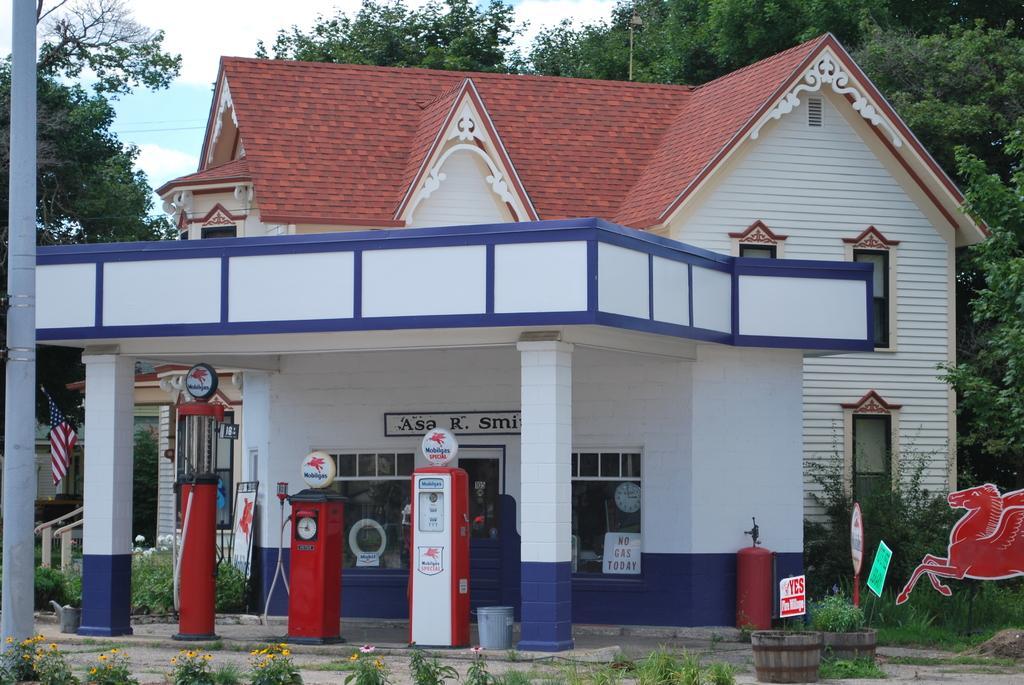Could you give a brief overview of what you see in this image? In this picture there is a gas station and there are few plants in front of it and there is a building behind the gas station and there are trees in the background and there is a pole in the left corner. 